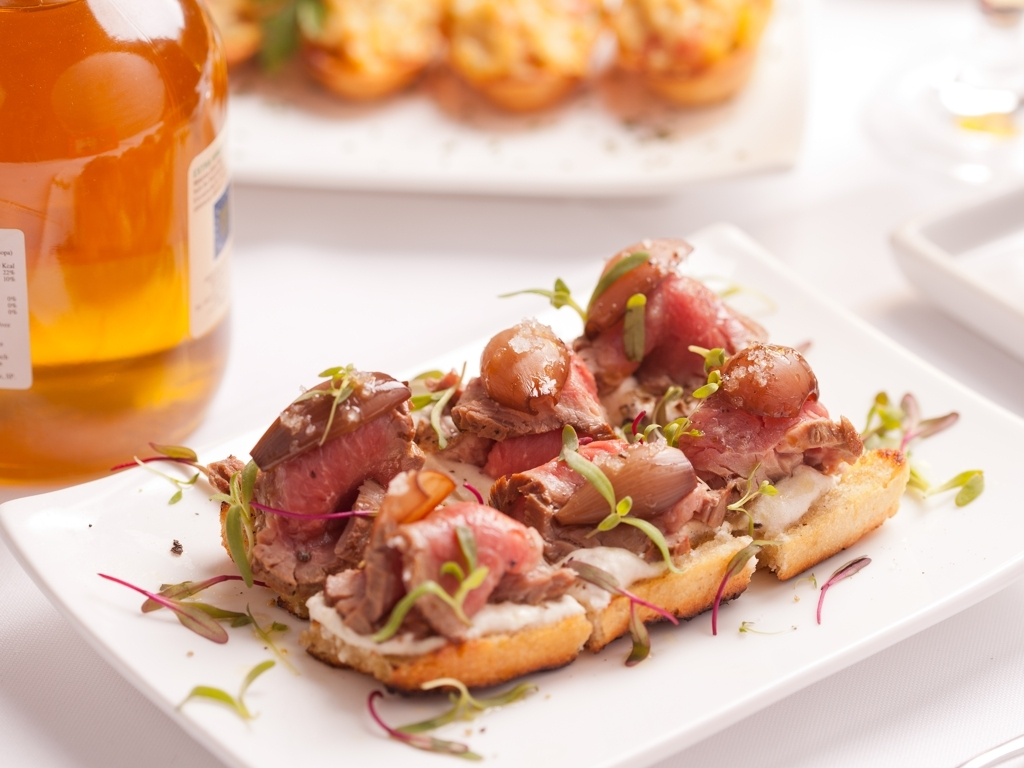Could you suggest an appropriate wine pairing for this dish? Considering the savory flavors and the possibility of red meat in the dish, a medium to full-bodied red wine such as a Chianti or a Merlot would complement it well. The tannins in the wine would balance the richness of the meat, and its fruity notes would resonate with any acidic components like pickled onions. 